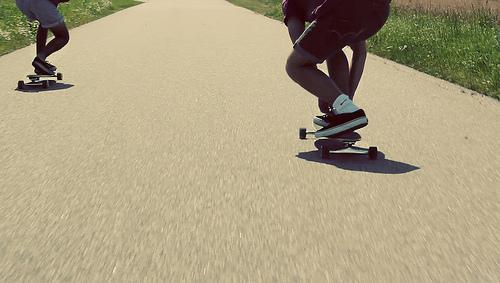How many skateboards?
Give a very brief answer. 2. 